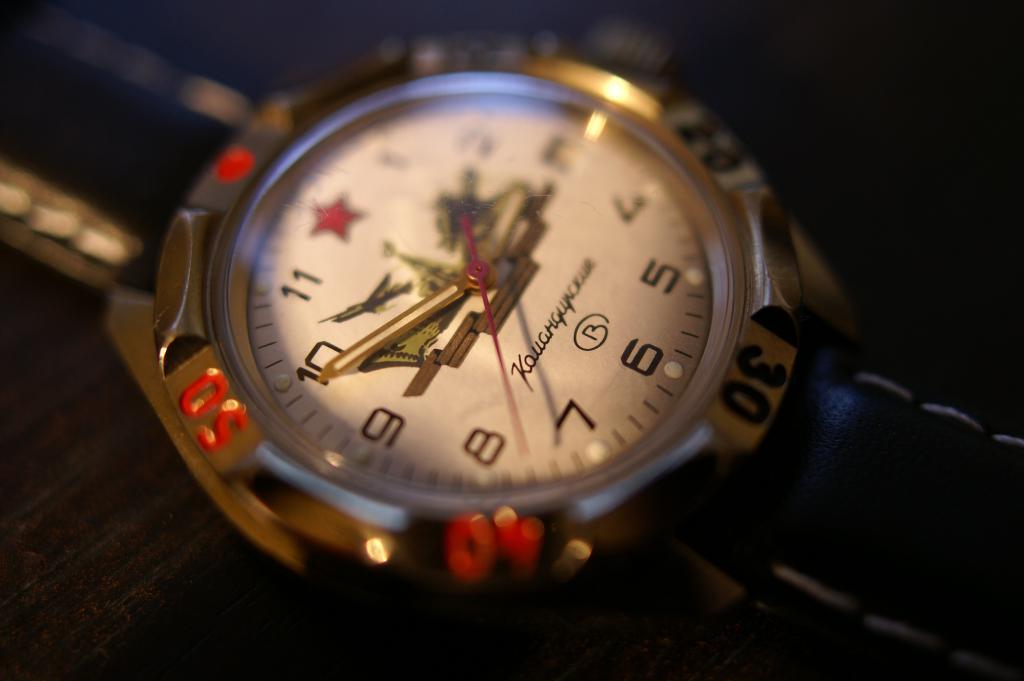What number is the minute hand closet t?
Provide a short and direct response. 10. 